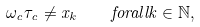Convert formula to latex. <formula><loc_0><loc_0><loc_500><loc_500>\omega _ { c } \tau _ { c } \neq x _ { k } \quad f o r a l l k \in \mathbb { N } ,</formula> 